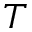<formula> <loc_0><loc_0><loc_500><loc_500>T</formula> 